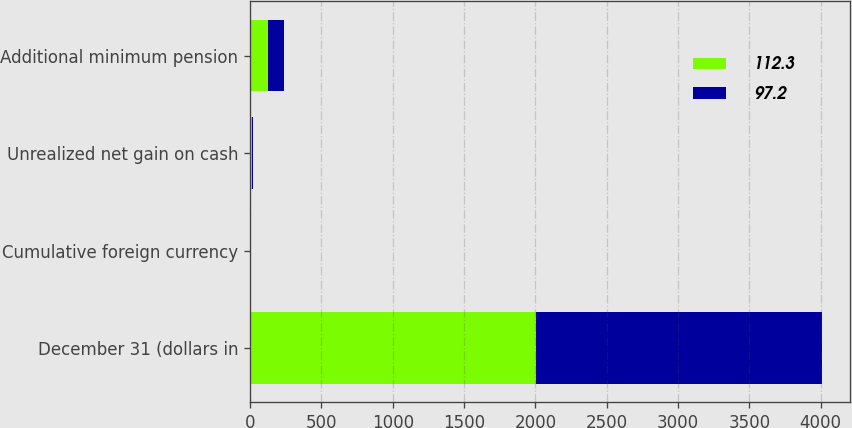Convert chart to OTSL. <chart><loc_0><loc_0><loc_500><loc_500><stacked_bar_chart><ecel><fcel>December 31 (dollars in<fcel>Cumulative foreign currency<fcel>Unrealized net gain on cash<fcel>Additional minimum pension<nl><fcel>112.3<fcel>2004<fcel>3.2<fcel>11.5<fcel>127<nl><fcel>97.2<fcel>2003<fcel>0.8<fcel>9.3<fcel>107.3<nl></chart> 